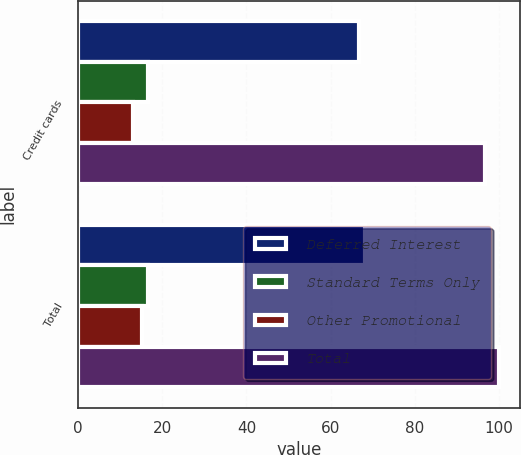Convert chart to OTSL. <chart><loc_0><loc_0><loc_500><loc_500><stacked_bar_chart><ecel><fcel>Credit cards<fcel>Total<nl><fcel>Deferred Interest<fcel>66.8<fcel>68.2<nl><fcel>Standard Terms Only<fcel>16.7<fcel>16.7<nl><fcel>Other Promotional<fcel>13.1<fcel>15.1<nl><fcel>Total<fcel>96.6<fcel>100<nl></chart> 